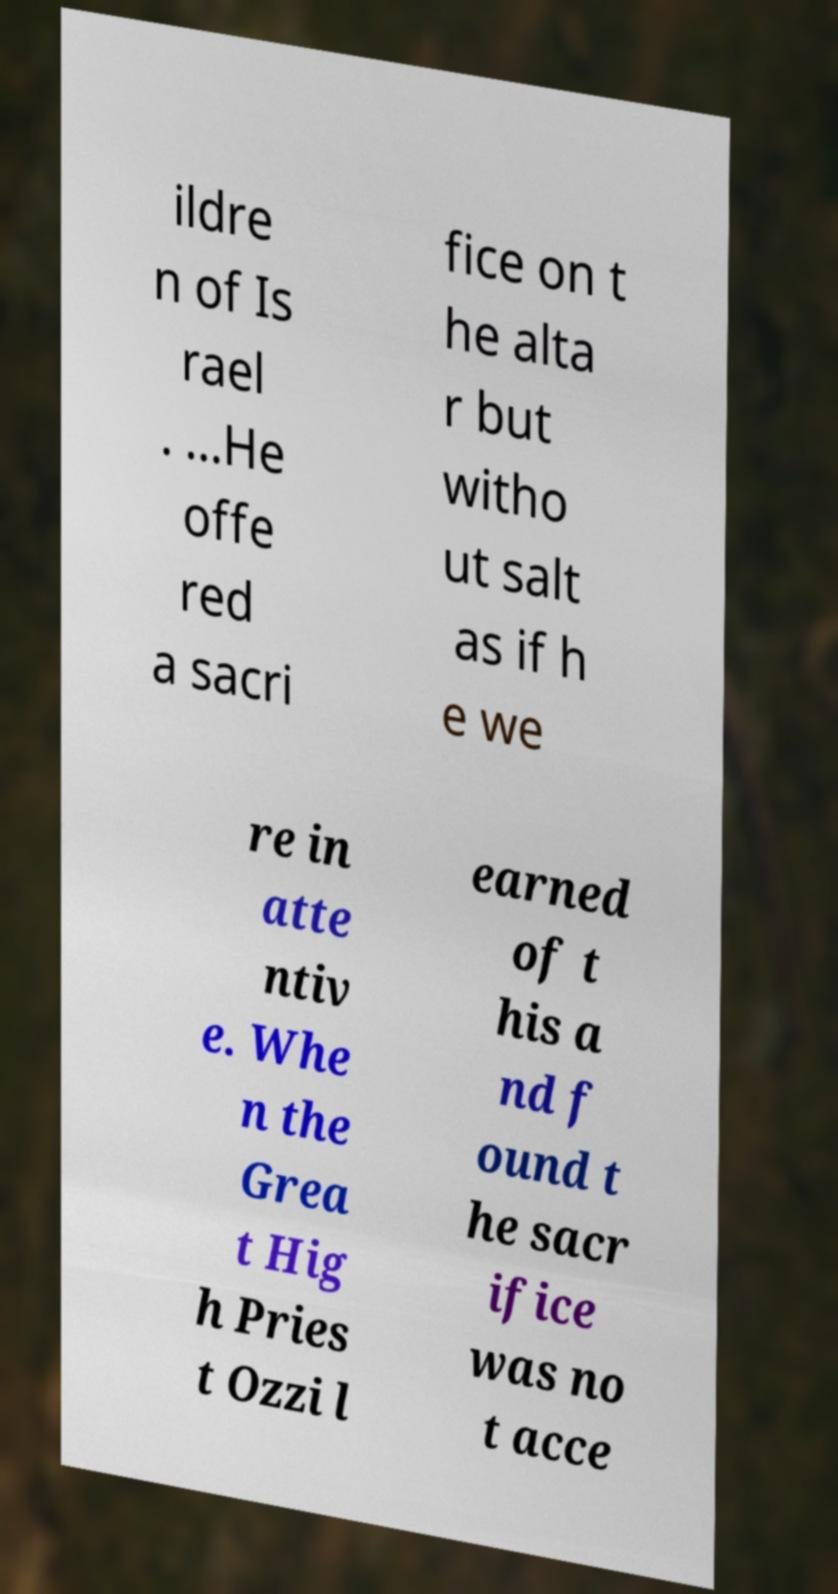Please identify and transcribe the text found in this image. ildre n of Is rael . ...He offe red a sacri fice on t he alta r but witho ut salt as if h e we re in atte ntiv e. Whe n the Grea t Hig h Pries t Ozzi l earned of t his a nd f ound t he sacr ifice was no t acce 